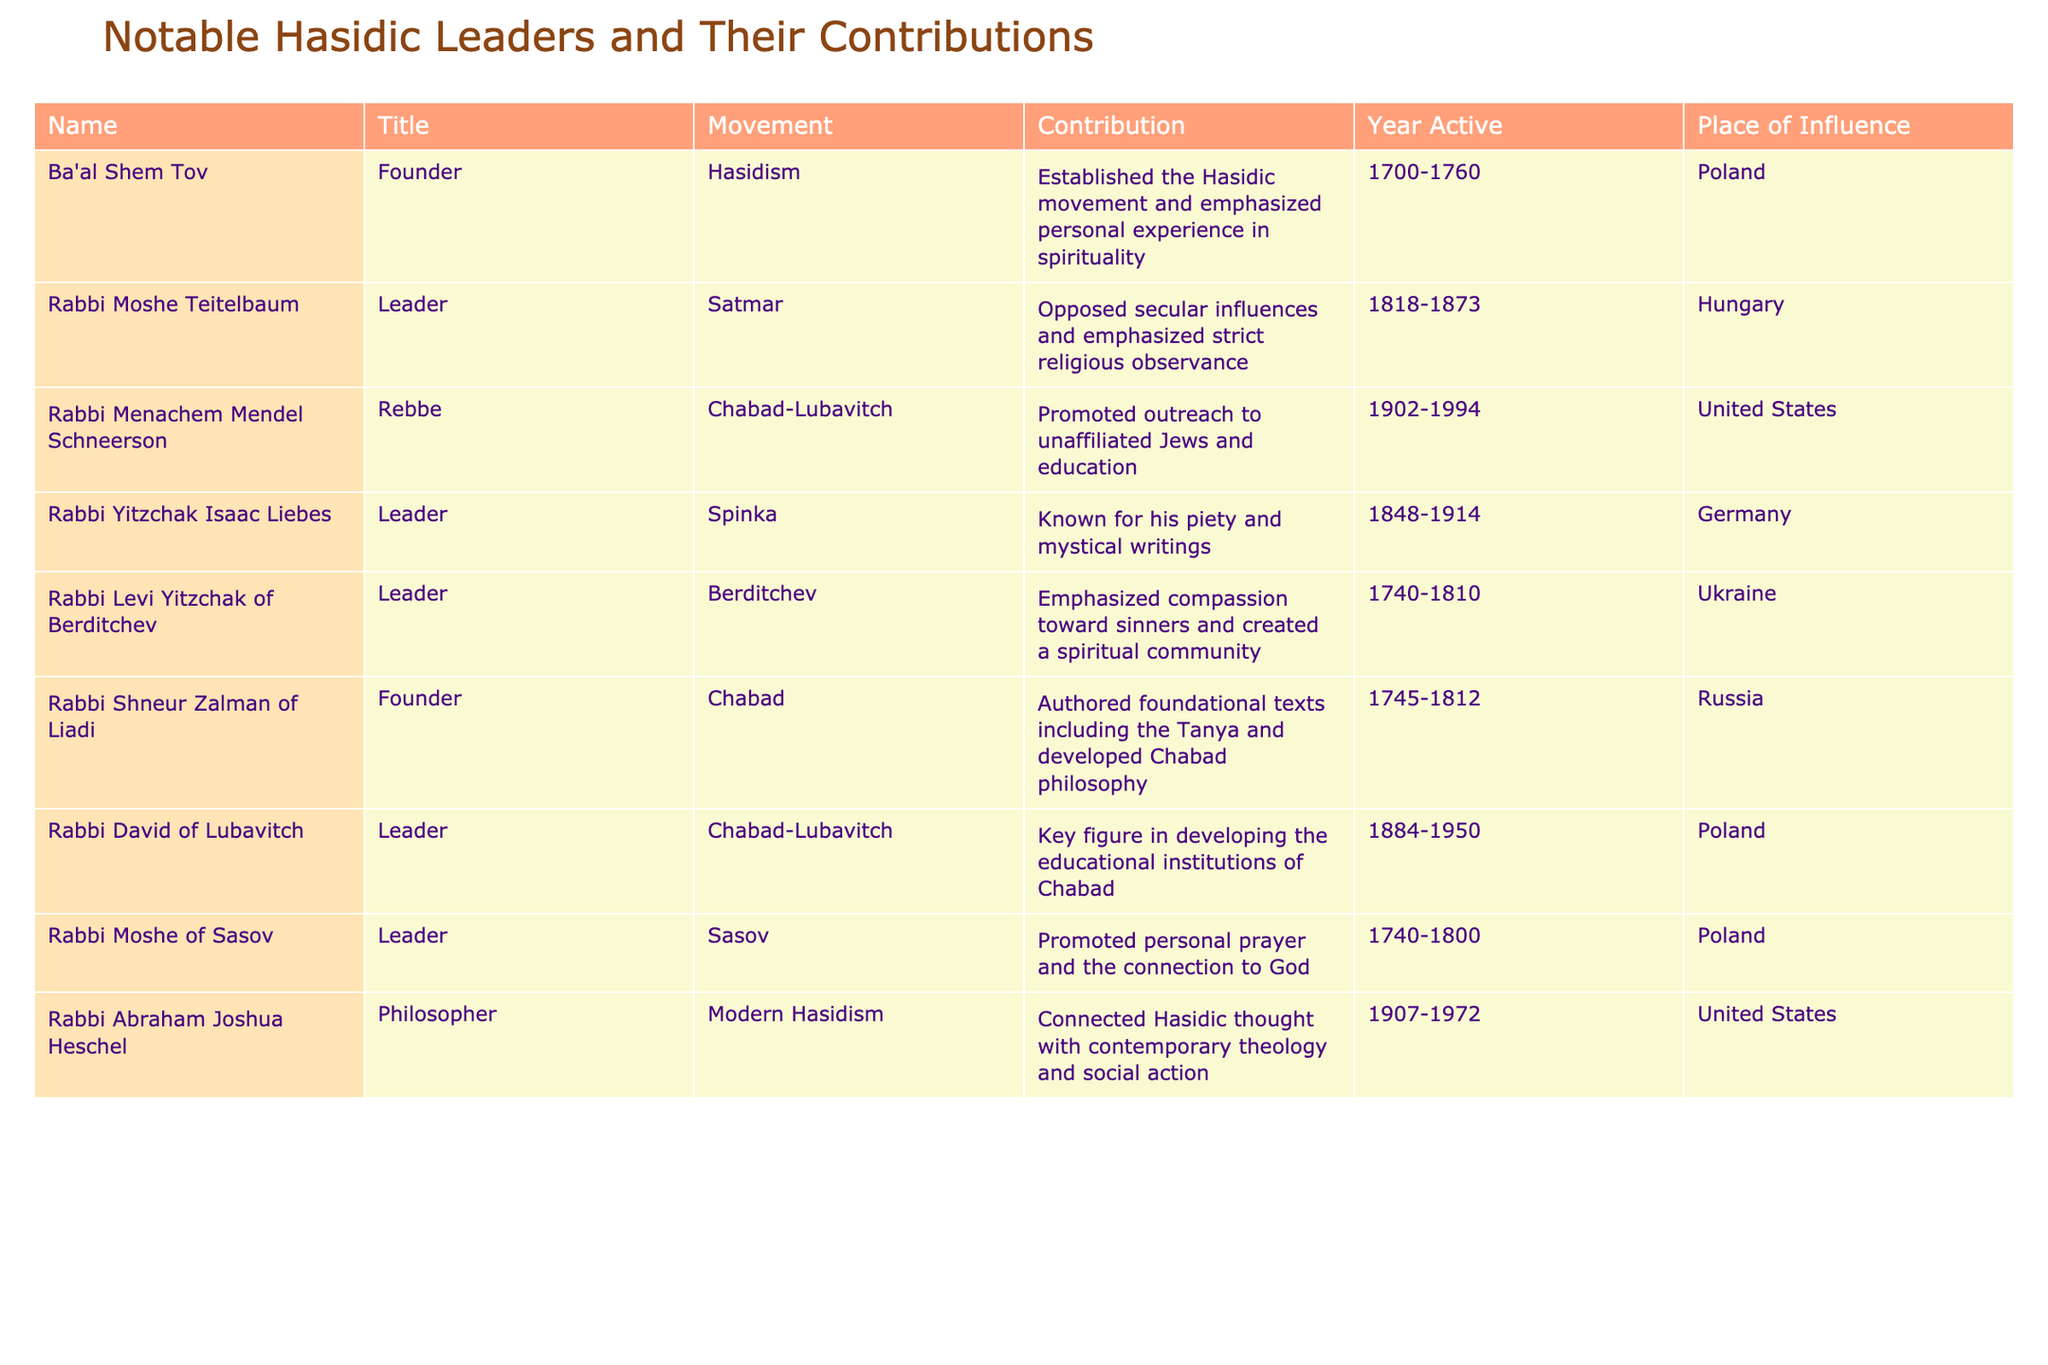What is the title of Rabbi Menachem Mendel Schneerson? According to the table, Rabbi Menachem Mendel Schneerson is listed with the title "Rebbe."
Answer: Rebbe Which movement did Rabbi Yitzchak Isaac Liebes belong to? The table indicates that Rabbi Yitzchak Isaac Liebes was a leader in the Spinka movement.
Answer: Spinka How many leaders were active in the 18th century? Looking at the "Year Active" column, the leaders active in the 18th century are Ba'al Shem Tov (1700-1760), Rabbi Levi Yitzchak of Berditchev (1740-1810), and Rabbi Shneur Zalman of Liadi (1745-1812). Counting these, there are three leaders.
Answer: 3 Did Rabbi Abraham Joshua Heschel emphasize the connection between Hasidic thought and social action? The table states that Rabbi Abraham Joshua Heschel connected Hasidic thought with contemporary theology and social action, indicating the statement is true.
Answer: Yes Which leader contributed to the establishment of educational institutions in Chabad? According to the table, Rabbi David of Lubavitch is noted as a key figure in developing the educational institutions of Chabad.
Answer: Rabbi David of Lubavitch What is the average year active span of the noted leaders in the table? To calculate the average, we first determine the active span for each leader. Then we sum the lengths of their active years: (1760-1700) + (1873-1818) + (1994-1902) + (1914-1848) + (1810-1740) + (1812-1745) + (1950-1884) + (1972-1907) = 60 + 55 + 92 + 66 + 70 + 67 + 66 + 65 = 491. There are 8 leaders, so the average is 491/8 = 61.375, which we can round to 61.
Answer: 61 Which location had the highest number of notable leaders from the table? By examining the "Place of Influence" column, we can see that Poland appears four times for Ba'al Shem Tov, Rabbi Moshe of Sasov, Rabbi David of Lubavitch, and Rabbi Menachem Mendel Schneerson, making it the location with the most leaders.
Answer: Poland What were the contributions of Rabbi Moshe Teitelbaum? The table specifies that Rabbi Moshe Teitelbaum opposed secular influences and emphasized strict religious observance.
Answer: Opposed secular influences and emphasized strict religious observance 